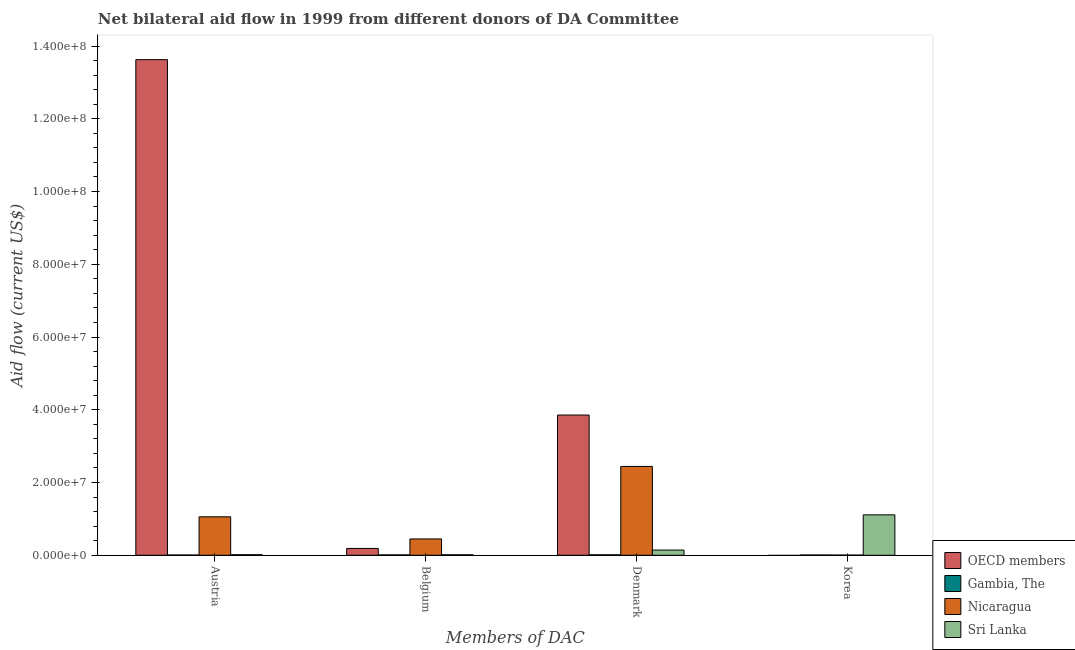Are the number of bars per tick equal to the number of legend labels?
Your answer should be very brief. No. Are the number of bars on each tick of the X-axis equal?
Your response must be concise. No. How many bars are there on the 4th tick from the left?
Offer a terse response. 3. What is the label of the 2nd group of bars from the left?
Make the answer very short. Belgium. What is the amount of aid given by korea in Nicaragua?
Ensure brevity in your answer.  5.00e+04. Across all countries, what is the maximum amount of aid given by denmark?
Your response must be concise. 3.86e+07. Across all countries, what is the minimum amount of aid given by denmark?
Your response must be concise. 1.20e+05. What is the total amount of aid given by korea in the graph?
Offer a very short reply. 1.12e+07. What is the difference between the amount of aid given by korea in Sri Lanka and that in Nicaragua?
Keep it short and to the point. 1.11e+07. What is the difference between the amount of aid given by austria in Nicaragua and the amount of aid given by denmark in Sri Lanka?
Ensure brevity in your answer.  9.14e+06. What is the average amount of aid given by denmark per country?
Make the answer very short. 1.61e+07. What is the difference between the amount of aid given by austria and amount of aid given by denmark in Sri Lanka?
Make the answer very short. -1.28e+06. What is the ratio of the amount of aid given by austria in Sri Lanka to that in OECD members?
Your answer should be compact. 0. Is the amount of aid given by austria in Sri Lanka less than that in Nicaragua?
Provide a short and direct response. Yes. Is the difference between the amount of aid given by belgium in Gambia, The and Sri Lanka greater than the difference between the amount of aid given by korea in Gambia, The and Sri Lanka?
Offer a very short reply. Yes. What is the difference between the highest and the second highest amount of aid given by belgium?
Ensure brevity in your answer.  2.61e+06. What is the difference between the highest and the lowest amount of aid given by austria?
Keep it short and to the point. 1.36e+08. In how many countries, is the amount of aid given by denmark greater than the average amount of aid given by denmark taken over all countries?
Make the answer very short. 2. Is it the case that in every country, the sum of the amount of aid given by belgium and amount of aid given by korea is greater than the sum of amount of aid given by denmark and amount of aid given by austria?
Your answer should be very brief. No. Are all the bars in the graph horizontal?
Offer a terse response. No. How many countries are there in the graph?
Ensure brevity in your answer.  4. What is the difference between two consecutive major ticks on the Y-axis?
Ensure brevity in your answer.  2.00e+07. How many legend labels are there?
Provide a short and direct response. 4. What is the title of the graph?
Provide a succinct answer. Net bilateral aid flow in 1999 from different donors of DA Committee. What is the label or title of the X-axis?
Offer a very short reply. Members of DAC. What is the label or title of the Y-axis?
Offer a terse response. Aid flow (current US$). What is the Aid flow (current US$) of OECD members in Austria?
Your answer should be compact. 1.36e+08. What is the Aid flow (current US$) of Nicaragua in Austria?
Ensure brevity in your answer.  1.06e+07. What is the Aid flow (current US$) in OECD members in Belgium?
Provide a short and direct response. 1.88e+06. What is the Aid flow (current US$) in Nicaragua in Belgium?
Your response must be concise. 4.49e+06. What is the Aid flow (current US$) in Sri Lanka in Belgium?
Your answer should be very brief. 1.40e+05. What is the Aid flow (current US$) in OECD members in Denmark?
Provide a short and direct response. 3.86e+07. What is the Aid flow (current US$) in Nicaragua in Denmark?
Provide a succinct answer. 2.44e+07. What is the Aid flow (current US$) of Sri Lanka in Denmark?
Offer a terse response. 1.43e+06. What is the Aid flow (current US$) in OECD members in Korea?
Offer a terse response. 0. What is the Aid flow (current US$) in Gambia, The in Korea?
Your answer should be compact. 7.00e+04. What is the Aid flow (current US$) of Sri Lanka in Korea?
Provide a short and direct response. 1.11e+07. Across all Members of DAC, what is the maximum Aid flow (current US$) of OECD members?
Give a very brief answer. 1.36e+08. Across all Members of DAC, what is the maximum Aid flow (current US$) of Gambia, The?
Give a very brief answer. 1.20e+05. Across all Members of DAC, what is the maximum Aid flow (current US$) in Nicaragua?
Provide a short and direct response. 2.44e+07. Across all Members of DAC, what is the maximum Aid flow (current US$) in Sri Lanka?
Your response must be concise. 1.11e+07. Across all Members of DAC, what is the minimum Aid flow (current US$) in OECD members?
Provide a short and direct response. 0. What is the total Aid flow (current US$) of OECD members in the graph?
Give a very brief answer. 1.77e+08. What is the total Aid flow (current US$) in Nicaragua in the graph?
Make the answer very short. 3.95e+07. What is the total Aid flow (current US$) of Sri Lanka in the graph?
Ensure brevity in your answer.  1.28e+07. What is the difference between the Aid flow (current US$) of OECD members in Austria and that in Belgium?
Your answer should be compact. 1.34e+08. What is the difference between the Aid flow (current US$) in Nicaragua in Austria and that in Belgium?
Keep it short and to the point. 6.08e+06. What is the difference between the Aid flow (current US$) of OECD members in Austria and that in Denmark?
Your answer should be very brief. 9.77e+07. What is the difference between the Aid flow (current US$) in Gambia, The in Austria and that in Denmark?
Keep it short and to the point. -5.00e+04. What is the difference between the Aid flow (current US$) in Nicaragua in Austria and that in Denmark?
Ensure brevity in your answer.  -1.38e+07. What is the difference between the Aid flow (current US$) in Sri Lanka in Austria and that in Denmark?
Make the answer very short. -1.28e+06. What is the difference between the Aid flow (current US$) in Gambia, The in Austria and that in Korea?
Make the answer very short. 0. What is the difference between the Aid flow (current US$) in Nicaragua in Austria and that in Korea?
Provide a succinct answer. 1.05e+07. What is the difference between the Aid flow (current US$) in Sri Lanka in Austria and that in Korea?
Make the answer very short. -1.10e+07. What is the difference between the Aid flow (current US$) in OECD members in Belgium and that in Denmark?
Your answer should be very brief. -3.67e+07. What is the difference between the Aid flow (current US$) of Gambia, The in Belgium and that in Denmark?
Your response must be concise. -2.00e+04. What is the difference between the Aid flow (current US$) in Nicaragua in Belgium and that in Denmark?
Provide a succinct answer. -1.99e+07. What is the difference between the Aid flow (current US$) of Sri Lanka in Belgium and that in Denmark?
Give a very brief answer. -1.29e+06. What is the difference between the Aid flow (current US$) of Nicaragua in Belgium and that in Korea?
Offer a very short reply. 4.44e+06. What is the difference between the Aid flow (current US$) in Sri Lanka in Belgium and that in Korea?
Your answer should be very brief. -1.10e+07. What is the difference between the Aid flow (current US$) in Nicaragua in Denmark and that in Korea?
Provide a short and direct response. 2.44e+07. What is the difference between the Aid flow (current US$) of Sri Lanka in Denmark and that in Korea?
Provide a succinct answer. -9.68e+06. What is the difference between the Aid flow (current US$) of OECD members in Austria and the Aid flow (current US$) of Gambia, The in Belgium?
Offer a very short reply. 1.36e+08. What is the difference between the Aid flow (current US$) of OECD members in Austria and the Aid flow (current US$) of Nicaragua in Belgium?
Provide a succinct answer. 1.32e+08. What is the difference between the Aid flow (current US$) of OECD members in Austria and the Aid flow (current US$) of Sri Lanka in Belgium?
Provide a short and direct response. 1.36e+08. What is the difference between the Aid flow (current US$) in Gambia, The in Austria and the Aid flow (current US$) in Nicaragua in Belgium?
Your answer should be compact. -4.42e+06. What is the difference between the Aid flow (current US$) of Gambia, The in Austria and the Aid flow (current US$) of Sri Lanka in Belgium?
Your answer should be compact. -7.00e+04. What is the difference between the Aid flow (current US$) of Nicaragua in Austria and the Aid flow (current US$) of Sri Lanka in Belgium?
Make the answer very short. 1.04e+07. What is the difference between the Aid flow (current US$) of OECD members in Austria and the Aid flow (current US$) of Gambia, The in Denmark?
Give a very brief answer. 1.36e+08. What is the difference between the Aid flow (current US$) of OECD members in Austria and the Aid flow (current US$) of Nicaragua in Denmark?
Provide a short and direct response. 1.12e+08. What is the difference between the Aid flow (current US$) in OECD members in Austria and the Aid flow (current US$) in Sri Lanka in Denmark?
Your answer should be compact. 1.35e+08. What is the difference between the Aid flow (current US$) in Gambia, The in Austria and the Aid flow (current US$) in Nicaragua in Denmark?
Ensure brevity in your answer.  -2.44e+07. What is the difference between the Aid flow (current US$) in Gambia, The in Austria and the Aid flow (current US$) in Sri Lanka in Denmark?
Your answer should be compact. -1.36e+06. What is the difference between the Aid flow (current US$) in Nicaragua in Austria and the Aid flow (current US$) in Sri Lanka in Denmark?
Give a very brief answer. 9.14e+06. What is the difference between the Aid flow (current US$) in OECD members in Austria and the Aid flow (current US$) in Gambia, The in Korea?
Keep it short and to the point. 1.36e+08. What is the difference between the Aid flow (current US$) in OECD members in Austria and the Aid flow (current US$) in Nicaragua in Korea?
Your answer should be compact. 1.36e+08. What is the difference between the Aid flow (current US$) of OECD members in Austria and the Aid flow (current US$) of Sri Lanka in Korea?
Your response must be concise. 1.25e+08. What is the difference between the Aid flow (current US$) in Gambia, The in Austria and the Aid flow (current US$) in Nicaragua in Korea?
Offer a terse response. 2.00e+04. What is the difference between the Aid flow (current US$) of Gambia, The in Austria and the Aid flow (current US$) of Sri Lanka in Korea?
Give a very brief answer. -1.10e+07. What is the difference between the Aid flow (current US$) in Nicaragua in Austria and the Aid flow (current US$) in Sri Lanka in Korea?
Ensure brevity in your answer.  -5.40e+05. What is the difference between the Aid flow (current US$) of OECD members in Belgium and the Aid flow (current US$) of Gambia, The in Denmark?
Provide a succinct answer. 1.76e+06. What is the difference between the Aid flow (current US$) in OECD members in Belgium and the Aid flow (current US$) in Nicaragua in Denmark?
Offer a very short reply. -2.25e+07. What is the difference between the Aid flow (current US$) in Gambia, The in Belgium and the Aid flow (current US$) in Nicaragua in Denmark?
Give a very brief answer. -2.43e+07. What is the difference between the Aid flow (current US$) of Gambia, The in Belgium and the Aid flow (current US$) of Sri Lanka in Denmark?
Keep it short and to the point. -1.33e+06. What is the difference between the Aid flow (current US$) in Nicaragua in Belgium and the Aid flow (current US$) in Sri Lanka in Denmark?
Offer a very short reply. 3.06e+06. What is the difference between the Aid flow (current US$) of OECD members in Belgium and the Aid flow (current US$) of Gambia, The in Korea?
Give a very brief answer. 1.81e+06. What is the difference between the Aid flow (current US$) in OECD members in Belgium and the Aid flow (current US$) in Nicaragua in Korea?
Your answer should be very brief. 1.83e+06. What is the difference between the Aid flow (current US$) of OECD members in Belgium and the Aid flow (current US$) of Sri Lanka in Korea?
Your answer should be compact. -9.23e+06. What is the difference between the Aid flow (current US$) in Gambia, The in Belgium and the Aid flow (current US$) in Nicaragua in Korea?
Your answer should be very brief. 5.00e+04. What is the difference between the Aid flow (current US$) of Gambia, The in Belgium and the Aid flow (current US$) of Sri Lanka in Korea?
Make the answer very short. -1.10e+07. What is the difference between the Aid flow (current US$) in Nicaragua in Belgium and the Aid flow (current US$) in Sri Lanka in Korea?
Your answer should be compact. -6.62e+06. What is the difference between the Aid flow (current US$) of OECD members in Denmark and the Aid flow (current US$) of Gambia, The in Korea?
Offer a terse response. 3.85e+07. What is the difference between the Aid flow (current US$) of OECD members in Denmark and the Aid flow (current US$) of Nicaragua in Korea?
Provide a succinct answer. 3.85e+07. What is the difference between the Aid flow (current US$) of OECD members in Denmark and the Aid flow (current US$) of Sri Lanka in Korea?
Offer a very short reply. 2.74e+07. What is the difference between the Aid flow (current US$) in Gambia, The in Denmark and the Aid flow (current US$) in Sri Lanka in Korea?
Your response must be concise. -1.10e+07. What is the difference between the Aid flow (current US$) in Nicaragua in Denmark and the Aid flow (current US$) in Sri Lanka in Korea?
Make the answer very short. 1.33e+07. What is the average Aid flow (current US$) in OECD members per Members of DAC?
Give a very brief answer. 4.42e+07. What is the average Aid flow (current US$) in Nicaragua per Members of DAC?
Your response must be concise. 9.88e+06. What is the average Aid flow (current US$) of Sri Lanka per Members of DAC?
Your answer should be compact. 3.21e+06. What is the difference between the Aid flow (current US$) of OECD members and Aid flow (current US$) of Gambia, The in Austria?
Provide a succinct answer. 1.36e+08. What is the difference between the Aid flow (current US$) in OECD members and Aid flow (current US$) in Nicaragua in Austria?
Provide a short and direct response. 1.26e+08. What is the difference between the Aid flow (current US$) of OECD members and Aid flow (current US$) of Sri Lanka in Austria?
Offer a very short reply. 1.36e+08. What is the difference between the Aid flow (current US$) of Gambia, The and Aid flow (current US$) of Nicaragua in Austria?
Offer a very short reply. -1.05e+07. What is the difference between the Aid flow (current US$) in Gambia, The and Aid flow (current US$) in Sri Lanka in Austria?
Offer a very short reply. -8.00e+04. What is the difference between the Aid flow (current US$) in Nicaragua and Aid flow (current US$) in Sri Lanka in Austria?
Offer a terse response. 1.04e+07. What is the difference between the Aid flow (current US$) in OECD members and Aid flow (current US$) in Gambia, The in Belgium?
Give a very brief answer. 1.78e+06. What is the difference between the Aid flow (current US$) of OECD members and Aid flow (current US$) of Nicaragua in Belgium?
Provide a short and direct response. -2.61e+06. What is the difference between the Aid flow (current US$) of OECD members and Aid flow (current US$) of Sri Lanka in Belgium?
Provide a succinct answer. 1.74e+06. What is the difference between the Aid flow (current US$) of Gambia, The and Aid flow (current US$) of Nicaragua in Belgium?
Keep it short and to the point. -4.39e+06. What is the difference between the Aid flow (current US$) in Nicaragua and Aid flow (current US$) in Sri Lanka in Belgium?
Ensure brevity in your answer.  4.35e+06. What is the difference between the Aid flow (current US$) in OECD members and Aid flow (current US$) in Gambia, The in Denmark?
Offer a very short reply. 3.84e+07. What is the difference between the Aid flow (current US$) in OECD members and Aid flow (current US$) in Nicaragua in Denmark?
Your response must be concise. 1.41e+07. What is the difference between the Aid flow (current US$) of OECD members and Aid flow (current US$) of Sri Lanka in Denmark?
Provide a short and direct response. 3.71e+07. What is the difference between the Aid flow (current US$) in Gambia, The and Aid flow (current US$) in Nicaragua in Denmark?
Keep it short and to the point. -2.43e+07. What is the difference between the Aid flow (current US$) in Gambia, The and Aid flow (current US$) in Sri Lanka in Denmark?
Ensure brevity in your answer.  -1.31e+06. What is the difference between the Aid flow (current US$) of Nicaragua and Aid flow (current US$) of Sri Lanka in Denmark?
Your answer should be compact. 2.30e+07. What is the difference between the Aid flow (current US$) in Gambia, The and Aid flow (current US$) in Nicaragua in Korea?
Keep it short and to the point. 2.00e+04. What is the difference between the Aid flow (current US$) of Gambia, The and Aid flow (current US$) of Sri Lanka in Korea?
Ensure brevity in your answer.  -1.10e+07. What is the difference between the Aid flow (current US$) in Nicaragua and Aid flow (current US$) in Sri Lanka in Korea?
Give a very brief answer. -1.11e+07. What is the ratio of the Aid flow (current US$) in OECD members in Austria to that in Belgium?
Offer a terse response. 72.47. What is the ratio of the Aid flow (current US$) of Nicaragua in Austria to that in Belgium?
Give a very brief answer. 2.35. What is the ratio of the Aid flow (current US$) of Sri Lanka in Austria to that in Belgium?
Ensure brevity in your answer.  1.07. What is the ratio of the Aid flow (current US$) in OECD members in Austria to that in Denmark?
Give a very brief answer. 3.53. What is the ratio of the Aid flow (current US$) in Gambia, The in Austria to that in Denmark?
Give a very brief answer. 0.58. What is the ratio of the Aid flow (current US$) of Nicaragua in Austria to that in Denmark?
Your response must be concise. 0.43. What is the ratio of the Aid flow (current US$) of Sri Lanka in Austria to that in Denmark?
Keep it short and to the point. 0.1. What is the ratio of the Aid flow (current US$) in Gambia, The in Austria to that in Korea?
Offer a terse response. 1. What is the ratio of the Aid flow (current US$) in Nicaragua in Austria to that in Korea?
Provide a short and direct response. 211.4. What is the ratio of the Aid flow (current US$) of Sri Lanka in Austria to that in Korea?
Keep it short and to the point. 0.01. What is the ratio of the Aid flow (current US$) in OECD members in Belgium to that in Denmark?
Provide a short and direct response. 0.05. What is the ratio of the Aid flow (current US$) of Gambia, The in Belgium to that in Denmark?
Ensure brevity in your answer.  0.83. What is the ratio of the Aid flow (current US$) in Nicaragua in Belgium to that in Denmark?
Make the answer very short. 0.18. What is the ratio of the Aid flow (current US$) in Sri Lanka in Belgium to that in Denmark?
Your response must be concise. 0.1. What is the ratio of the Aid flow (current US$) in Gambia, The in Belgium to that in Korea?
Provide a short and direct response. 1.43. What is the ratio of the Aid flow (current US$) in Nicaragua in Belgium to that in Korea?
Ensure brevity in your answer.  89.8. What is the ratio of the Aid flow (current US$) of Sri Lanka in Belgium to that in Korea?
Give a very brief answer. 0.01. What is the ratio of the Aid flow (current US$) of Gambia, The in Denmark to that in Korea?
Give a very brief answer. 1.71. What is the ratio of the Aid flow (current US$) of Nicaragua in Denmark to that in Korea?
Offer a terse response. 488.4. What is the ratio of the Aid flow (current US$) in Sri Lanka in Denmark to that in Korea?
Keep it short and to the point. 0.13. What is the difference between the highest and the second highest Aid flow (current US$) of OECD members?
Your answer should be very brief. 9.77e+07. What is the difference between the highest and the second highest Aid flow (current US$) of Nicaragua?
Keep it short and to the point. 1.38e+07. What is the difference between the highest and the second highest Aid flow (current US$) in Sri Lanka?
Give a very brief answer. 9.68e+06. What is the difference between the highest and the lowest Aid flow (current US$) in OECD members?
Ensure brevity in your answer.  1.36e+08. What is the difference between the highest and the lowest Aid flow (current US$) of Gambia, The?
Your answer should be very brief. 5.00e+04. What is the difference between the highest and the lowest Aid flow (current US$) in Nicaragua?
Your answer should be very brief. 2.44e+07. What is the difference between the highest and the lowest Aid flow (current US$) in Sri Lanka?
Provide a succinct answer. 1.10e+07. 